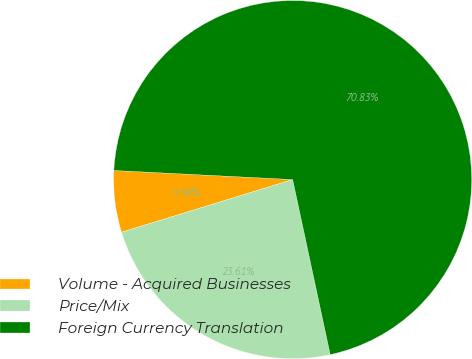Convert chart to OTSL. <chart><loc_0><loc_0><loc_500><loc_500><pie_chart><fcel>Volume - Acquired Businesses<fcel>Price/Mix<fcel>Foreign Currency Translation<nl><fcel>5.56%<fcel>23.61%<fcel>70.83%<nl></chart> 